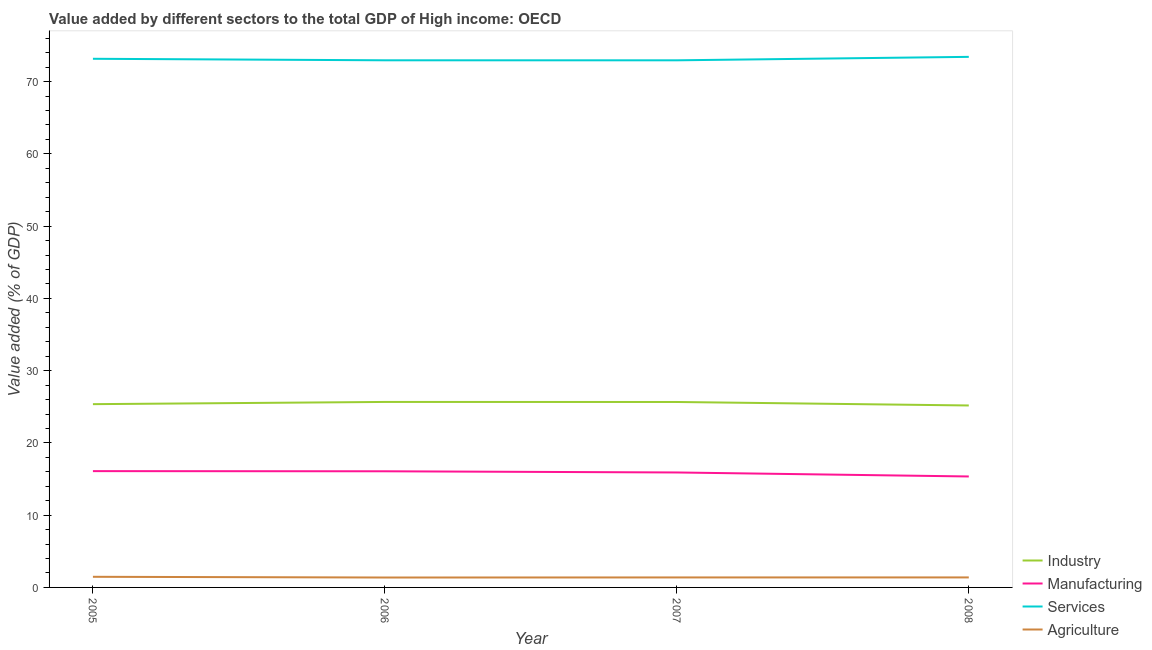How many different coloured lines are there?
Provide a short and direct response. 4. Does the line corresponding to value added by manufacturing sector intersect with the line corresponding to value added by agricultural sector?
Ensure brevity in your answer.  No. What is the value added by services sector in 2008?
Provide a succinct answer. 73.43. Across all years, what is the maximum value added by industrial sector?
Give a very brief answer. 25.67. Across all years, what is the minimum value added by manufacturing sector?
Provide a succinct answer. 15.36. What is the total value added by services sector in the graph?
Keep it short and to the point. 292.5. What is the difference between the value added by services sector in 2006 and that in 2007?
Your answer should be compact. 0. What is the difference between the value added by manufacturing sector in 2007 and the value added by industrial sector in 2005?
Ensure brevity in your answer.  -9.45. What is the average value added by manufacturing sector per year?
Your response must be concise. 15.86. In the year 2006, what is the difference between the value added by services sector and value added by manufacturing sector?
Provide a short and direct response. 56.88. In how many years, is the value added by manufacturing sector greater than 36 %?
Ensure brevity in your answer.  0. What is the ratio of the value added by agricultural sector in 2005 to that in 2007?
Offer a very short reply. 1.06. What is the difference between the highest and the second highest value added by services sector?
Keep it short and to the point. 0.27. What is the difference between the highest and the lowest value added by industrial sector?
Offer a very short reply. 0.49. In how many years, is the value added by services sector greater than the average value added by services sector taken over all years?
Your response must be concise. 2. Is it the case that in every year, the sum of the value added by services sector and value added by industrial sector is greater than the sum of value added by manufacturing sector and value added by agricultural sector?
Your response must be concise. Yes. Does the value added by services sector monotonically increase over the years?
Your answer should be compact. No. Is the value added by services sector strictly less than the value added by manufacturing sector over the years?
Provide a succinct answer. No. What is the difference between two consecutive major ticks on the Y-axis?
Provide a succinct answer. 10. Are the values on the major ticks of Y-axis written in scientific E-notation?
Ensure brevity in your answer.  No. Does the graph contain grids?
Your answer should be compact. No. How many legend labels are there?
Provide a succinct answer. 4. How are the legend labels stacked?
Your answer should be very brief. Vertical. What is the title of the graph?
Your response must be concise. Value added by different sectors to the total GDP of High income: OECD. Does "Social Insurance" appear as one of the legend labels in the graph?
Your response must be concise. No. What is the label or title of the Y-axis?
Ensure brevity in your answer.  Value added (% of GDP). What is the Value added (% of GDP) of Industry in 2005?
Ensure brevity in your answer.  25.36. What is the Value added (% of GDP) in Manufacturing in 2005?
Offer a terse response. 16.1. What is the Value added (% of GDP) of Services in 2005?
Offer a very short reply. 73.16. What is the Value added (% of GDP) of Agriculture in 2005?
Your response must be concise. 1.47. What is the Value added (% of GDP) in Industry in 2006?
Your answer should be very brief. 25.67. What is the Value added (% of GDP) of Manufacturing in 2006?
Keep it short and to the point. 16.07. What is the Value added (% of GDP) of Services in 2006?
Give a very brief answer. 72.96. What is the Value added (% of GDP) in Agriculture in 2006?
Keep it short and to the point. 1.37. What is the Value added (% of GDP) of Industry in 2007?
Offer a terse response. 25.67. What is the Value added (% of GDP) in Manufacturing in 2007?
Make the answer very short. 15.91. What is the Value added (% of GDP) of Services in 2007?
Offer a terse response. 72.95. What is the Value added (% of GDP) of Agriculture in 2007?
Your answer should be compact. 1.38. What is the Value added (% of GDP) in Industry in 2008?
Make the answer very short. 25.18. What is the Value added (% of GDP) in Manufacturing in 2008?
Offer a very short reply. 15.36. What is the Value added (% of GDP) in Services in 2008?
Make the answer very short. 73.43. What is the Value added (% of GDP) in Agriculture in 2008?
Keep it short and to the point. 1.39. Across all years, what is the maximum Value added (% of GDP) of Industry?
Provide a succinct answer. 25.67. Across all years, what is the maximum Value added (% of GDP) in Manufacturing?
Your answer should be very brief. 16.1. Across all years, what is the maximum Value added (% of GDP) of Services?
Provide a short and direct response. 73.43. Across all years, what is the maximum Value added (% of GDP) of Agriculture?
Offer a very short reply. 1.47. Across all years, what is the minimum Value added (% of GDP) in Industry?
Make the answer very short. 25.18. Across all years, what is the minimum Value added (% of GDP) in Manufacturing?
Provide a short and direct response. 15.36. Across all years, what is the minimum Value added (% of GDP) in Services?
Offer a very short reply. 72.95. Across all years, what is the minimum Value added (% of GDP) of Agriculture?
Offer a very short reply. 1.37. What is the total Value added (% of GDP) of Industry in the graph?
Your response must be concise. 101.88. What is the total Value added (% of GDP) in Manufacturing in the graph?
Offer a very short reply. 63.44. What is the total Value added (% of GDP) in Services in the graph?
Keep it short and to the point. 292.5. What is the total Value added (% of GDP) of Agriculture in the graph?
Ensure brevity in your answer.  5.61. What is the difference between the Value added (% of GDP) in Industry in 2005 and that in 2006?
Give a very brief answer. -0.31. What is the difference between the Value added (% of GDP) of Manufacturing in 2005 and that in 2006?
Ensure brevity in your answer.  0.02. What is the difference between the Value added (% of GDP) of Services in 2005 and that in 2006?
Ensure brevity in your answer.  0.21. What is the difference between the Value added (% of GDP) of Agriculture in 2005 and that in 2006?
Offer a very short reply. 0.1. What is the difference between the Value added (% of GDP) in Industry in 2005 and that in 2007?
Make the answer very short. -0.3. What is the difference between the Value added (% of GDP) in Manufacturing in 2005 and that in 2007?
Offer a terse response. 0.18. What is the difference between the Value added (% of GDP) of Services in 2005 and that in 2007?
Make the answer very short. 0.21. What is the difference between the Value added (% of GDP) in Agriculture in 2005 and that in 2007?
Offer a very short reply. 0.09. What is the difference between the Value added (% of GDP) of Industry in 2005 and that in 2008?
Your response must be concise. 0.18. What is the difference between the Value added (% of GDP) of Manufacturing in 2005 and that in 2008?
Provide a succinct answer. 0.74. What is the difference between the Value added (% of GDP) in Services in 2005 and that in 2008?
Keep it short and to the point. -0.27. What is the difference between the Value added (% of GDP) in Agriculture in 2005 and that in 2008?
Keep it short and to the point. 0.09. What is the difference between the Value added (% of GDP) in Industry in 2006 and that in 2007?
Your answer should be very brief. 0.01. What is the difference between the Value added (% of GDP) of Manufacturing in 2006 and that in 2007?
Provide a short and direct response. 0.16. What is the difference between the Value added (% of GDP) of Services in 2006 and that in 2007?
Provide a short and direct response. 0. What is the difference between the Value added (% of GDP) of Agriculture in 2006 and that in 2007?
Provide a succinct answer. -0.01. What is the difference between the Value added (% of GDP) of Industry in 2006 and that in 2008?
Give a very brief answer. 0.49. What is the difference between the Value added (% of GDP) of Manufacturing in 2006 and that in 2008?
Make the answer very short. 0.72. What is the difference between the Value added (% of GDP) in Services in 2006 and that in 2008?
Make the answer very short. -0.48. What is the difference between the Value added (% of GDP) in Agriculture in 2006 and that in 2008?
Your response must be concise. -0.01. What is the difference between the Value added (% of GDP) in Industry in 2007 and that in 2008?
Make the answer very short. 0.48. What is the difference between the Value added (% of GDP) in Manufacturing in 2007 and that in 2008?
Ensure brevity in your answer.  0.56. What is the difference between the Value added (% of GDP) in Services in 2007 and that in 2008?
Give a very brief answer. -0.48. What is the difference between the Value added (% of GDP) in Agriculture in 2007 and that in 2008?
Make the answer very short. -0. What is the difference between the Value added (% of GDP) in Industry in 2005 and the Value added (% of GDP) in Manufacturing in 2006?
Provide a succinct answer. 9.29. What is the difference between the Value added (% of GDP) of Industry in 2005 and the Value added (% of GDP) of Services in 2006?
Ensure brevity in your answer.  -47.59. What is the difference between the Value added (% of GDP) of Industry in 2005 and the Value added (% of GDP) of Agriculture in 2006?
Offer a very short reply. 23.99. What is the difference between the Value added (% of GDP) of Manufacturing in 2005 and the Value added (% of GDP) of Services in 2006?
Give a very brief answer. -56.86. What is the difference between the Value added (% of GDP) of Manufacturing in 2005 and the Value added (% of GDP) of Agriculture in 2006?
Give a very brief answer. 14.72. What is the difference between the Value added (% of GDP) in Services in 2005 and the Value added (% of GDP) in Agriculture in 2006?
Offer a terse response. 71.79. What is the difference between the Value added (% of GDP) in Industry in 2005 and the Value added (% of GDP) in Manufacturing in 2007?
Your answer should be very brief. 9.45. What is the difference between the Value added (% of GDP) of Industry in 2005 and the Value added (% of GDP) of Services in 2007?
Your response must be concise. -47.59. What is the difference between the Value added (% of GDP) in Industry in 2005 and the Value added (% of GDP) in Agriculture in 2007?
Offer a terse response. 23.98. What is the difference between the Value added (% of GDP) in Manufacturing in 2005 and the Value added (% of GDP) in Services in 2007?
Ensure brevity in your answer.  -56.86. What is the difference between the Value added (% of GDP) of Manufacturing in 2005 and the Value added (% of GDP) of Agriculture in 2007?
Offer a terse response. 14.71. What is the difference between the Value added (% of GDP) in Services in 2005 and the Value added (% of GDP) in Agriculture in 2007?
Provide a short and direct response. 71.78. What is the difference between the Value added (% of GDP) in Industry in 2005 and the Value added (% of GDP) in Manufacturing in 2008?
Your response must be concise. 10.01. What is the difference between the Value added (% of GDP) in Industry in 2005 and the Value added (% of GDP) in Services in 2008?
Make the answer very short. -48.07. What is the difference between the Value added (% of GDP) of Industry in 2005 and the Value added (% of GDP) of Agriculture in 2008?
Make the answer very short. 23.98. What is the difference between the Value added (% of GDP) of Manufacturing in 2005 and the Value added (% of GDP) of Services in 2008?
Your answer should be very brief. -57.34. What is the difference between the Value added (% of GDP) of Manufacturing in 2005 and the Value added (% of GDP) of Agriculture in 2008?
Offer a terse response. 14.71. What is the difference between the Value added (% of GDP) in Services in 2005 and the Value added (% of GDP) in Agriculture in 2008?
Provide a succinct answer. 71.78. What is the difference between the Value added (% of GDP) in Industry in 2006 and the Value added (% of GDP) in Manufacturing in 2007?
Offer a very short reply. 9.76. What is the difference between the Value added (% of GDP) in Industry in 2006 and the Value added (% of GDP) in Services in 2007?
Your response must be concise. -47.28. What is the difference between the Value added (% of GDP) of Industry in 2006 and the Value added (% of GDP) of Agriculture in 2007?
Provide a succinct answer. 24.29. What is the difference between the Value added (% of GDP) of Manufacturing in 2006 and the Value added (% of GDP) of Services in 2007?
Give a very brief answer. -56.88. What is the difference between the Value added (% of GDP) in Manufacturing in 2006 and the Value added (% of GDP) in Agriculture in 2007?
Make the answer very short. 14.69. What is the difference between the Value added (% of GDP) of Services in 2006 and the Value added (% of GDP) of Agriculture in 2007?
Provide a succinct answer. 71.57. What is the difference between the Value added (% of GDP) in Industry in 2006 and the Value added (% of GDP) in Manufacturing in 2008?
Your answer should be compact. 10.32. What is the difference between the Value added (% of GDP) in Industry in 2006 and the Value added (% of GDP) in Services in 2008?
Offer a terse response. -47.76. What is the difference between the Value added (% of GDP) of Industry in 2006 and the Value added (% of GDP) of Agriculture in 2008?
Offer a very short reply. 24.29. What is the difference between the Value added (% of GDP) of Manufacturing in 2006 and the Value added (% of GDP) of Services in 2008?
Give a very brief answer. -57.36. What is the difference between the Value added (% of GDP) in Manufacturing in 2006 and the Value added (% of GDP) in Agriculture in 2008?
Offer a terse response. 14.69. What is the difference between the Value added (% of GDP) of Services in 2006 and the Value added (% of GDP) of Agriculture in 2008?
Your answer should be compact. 71.57. What is the difference between the Value added (% of GDP) of Industry in 2007 and the Value added (% of GDP) of Manufacturing in 2008?
Your answer should be compact. 10.31. What is the difference between the Value added (% of GDP) of Industry in 2007 and the Value added (% of GDP) of Services in 2008?
Your answer should be compact. -47.77. What is the difference between the Value added (% of GDP) of Industry in 2007 and the Value added (% of GDP) of Agriculture in 2008?
Keep it short and to the point. 24.28. What is the difference between the Value added (% of GDP) of Manufacturing in 2007 and the Value added (% of GDP) of Services in 2008?
Your response must be concise. -57.52. What is the difference between the Value added (% of GDP) of Manufacturing in 2007 and the Value added (% of GDP) of Agriculture in 2008?
Your answer should be very brief. 14.53. What is the difference between the Value added (% of GDP) of Services in 2007 and the Value added (% of GDP) of Agriculture in 2008?
Keep it short and to the point. 71.57. What is the average Value added (% of GDP) in Industry per year?
Give a very brief answer. 25.47. What is the average Value added (% of GDP) in Manufacturing per year?
Provide a short and direct response. 15.86. What is the average Value added (% of GDP) in Services per year?
Offer a terse response. 73.13. What is the average Value added (% of GDP) in Agriculture per year?
Provide a succinct answer. 1.4. In the year 2005, what is the difference between the Value added (% of GDP) in Industry and Value added (% of GDP) in Manufacturing?
Keep it short and to the point. 9.27. In the year 2005, what is the difference between the Value added (% of GDP) of Industry and Value added (% of GDP) of Services?
Your answer should be very brief. -47.8. In the year 2005, what is the difference between the Value added (% of GDP) in Industry and Value added (% of GDP) in Agriculture?
Offer a terse response. 23.89. In the year 2005, what is the difference between the Value added (% of GDP) of Manufacturing and Value added (% of GDP) of Services?
Your answer should be compact. -57.07. In the year 2005, what is the difference between the Value added (% of GDP) in Manufacturing and Value added (% of GDP) in Agriculture?
Provide a succinct answer. 14.62. In the year 2005, what is the difference between the Value added (% of GDP) of Services and Value added (% of GDP) of Agriculture?
Make the answer very short. 71.69. In the year 2006, what is the difference between the Value added (% of GDP) in Industry and Value added (% of GDP) in Manufacturing?
Ensure brevity in your answer.  9.6. In the year 2006, what is the difference between the Value added (% of GDP) in Industry and Value added (% of GDP) in Services?
Provide a short and direct response. -47.28. In the year 2006, what is the difference between the Value added (% of GDP) of Industry and Value added (% of GDP) of Agriculture?
Keep it short and to the point. 24.3. In the year 2006, what is the difference between the Value added (% of GDP) in Manufacturing and Value added (% of GDP) in Services?
Your answer should be compact. -56.88. In the year 2006, what is the difference between the Value added (% of GDP) of Manufacturing and Value added (% of GDP) of Agriculture?
Offer a very short reply. 14.7. In the year 2006, what is the difference between the Value added (% of GDP) in Services and Value added (% of GDP) in Agriculture?
Offer a very short reply. 71.58. In the year 2007, what is the difference between the Value added (% of GDP) in Industry and Value added (% of GDP) in Manufacturing?
Keep it short and to the point. 9.75. In the year 2007, what is the difference between the Value added (% of GDP) in Industry and Value added (% of GDP) in Services?
Your answer should be very brief. -47.29. In the year 2007, what is the difference between the Value added (% of GDP) in Industry and Value added (% of GDP) in Agriculture?
Your response must be concise. 24.28. In the year 2007, what is the difference between the Value added (% of GDP) in Manufacturing and Value added (% of GDP) in Services?
Provide a succinct answer. -57.04. In the year 2007, what is the difference between the Value added (% of GDP) of Manufacturing and Value added (% of GDP) of Agriculture?
Your answer should be compact. 14.53. In the year 2007, what is the difference between the Value added (% of GDP) in Services and Value added (% of GDP) in Agriculture?
Keep it short and to the point. 71.57. In the year 2008, what is the difference between the Value added (% of GDP) in Industry and Value added (% of GDP) in Manufacturing?
Ensure brevity in your answer.  9.83. In the year 2008, what is the difference between the Value added (% of GDP) of Industry and Value added (% of GDP) of Services?
Offer a terse response. -48.25. In the year 2008, what is the difference between the Value added (% of GDP) of Industry and Value added (% of GDP) of Agriculture?
Provide a succinct answer. 23.8. In the year 2008, what is the difference between the Value added (% of GDP) of Manufacturing and Value added (% of GDP) of Services?
Your answer should be very brief. -58.07. In the year 2008, what is the difference between the Value added (% of GDP) in Manufacturing and Value added (% of GDP) in Agriculture?
Your response must be concise. 13.97. In the year 2008, what is the difference between the Value added (% of GDP) of Services and Value added (% of GDP) of Agriculture?
Your answer should be compact. 72.05. What is the ratio of the Value added (% of GDP) of Industry in 2005 to that in 2006?
Ensure brevity in your answer.  0.99. What is the ratio of the Value added (% of GDP) in Manufacturing in 2005 to that in 2006?
Offer a terse response. 1. What is the ratio of the Value added (% of GDP) in Agriculture in 2005 to that in 2006?
Keep it short and to the point. 1.07. What is the ratio of the Value added (% of GDP) in Manufacturing in 2005 to that in 2007?
Your response must be concise. 1.01. What is the ratio of the Value added (% of GDP) of Agriculture in 2005 to that in 2007?
Make the answer very short. 1.06. What is the ratio of the Value added (% of GDP) of Industry in 2005 to that in 2008?
Make the answer very short. 1.01. What is the ratio of the Value added (% of GDP) in Manufacturing in 2005 to that in 2008?
Your answer should be very brief. 1.05. What is the ratio of the Value added (% of GDP) of Agriculture in 2005 to that in 2008?
Your answer should be compact. 1.06. What is the ratio of the Value added (% of GDP) of Manufacturing in 2006 to that in 2007?
Keep it short and to the point. 1.01. What is the ratio of the Value added (% of GDP) in Services in 2006 to that in 2007?
Keep it short and to the point. 1. What is the ratio of the Value added (% of GDP) in Agriculture in 2006 to that in 2007?
Provide a succinct answer. 0.99. What is the ratio of the Value added (% of GDP) in Industry in 2006 to that in 2008?
Your answer should be very brief. 1.02. What is the ratio of the Value added (% of GDP) of Manufacturing in 2006 to that in 2008?
Ensure brevity in your answer.  1.05. What is the ratio of the Value added (% of GDP) of Services in 2006 to that in 2008?
Provide a succinct answer. 0.99. What is the ratio of the Value added (% of GDP) in Agriculture in 2006 to that in 2008?
Keep it short and to the point. 0.99. What is the ratio of the Value added (% of GDP) in Industry in 2007 to that in 2008?
Your answer should be very brief. 1.02. What is the ratio of the Value added (% of GDP) of Manufacturing in 2007 to that in 2008?
Ensure brevity in your answer.  1.04. What is the ratio of the Value added (% of GDP) in Agriculture in 2007 to that in 2008?
Ensure brevity in your answer.  1. What is the difference between the highest and the second highest Value added (% of GDP) in Industry?
Your response must be concise. 0.01. What is the difference between the highest and the second highest Value added (% of GDP) of Manufacturing?
Ensure brevity in your answer.  0.02. What is the difference between the highest and the second highest Value added (% of GDP) of Services?
Your response must be concise. 0.27. What is the difference between the highest and the second highest Value added (% of GDP) of Agriculture?
Make the answer very short. 0.09. What is the difference between the highest and the lowest Value added (% of GDP) in Industry?
Offer a terse response. 0.49. What is the difference between the highest and the lowest Value added (% of GDP) of Manufacturing?
Offer a terse response. 0.74. What is the difference between the highest and the lowest Value added (% of GDP) of Services?
Offer a very short reply. 0.48. What is the difference between the highest and the lowest Value added (% of GDP) of Agriculture?
Ensure brevity in your answer.  0.1. 